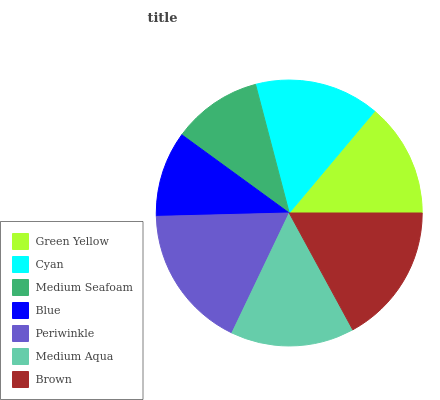Is Blue the minimum?
Answer yes or no. Yes. Is Periwinkle the maximum?
Answer yes or no. Yes. Is Cyan the minimum?
Answer yes or no. No. Is Cyan the maximum?
Answer yes or no. No. Is Cyan greater than Green Yellow?
Answer yes or no. Yes. Is Green Yellow less than Cyan?
Answer yes or no. Yes. Is Green Yellow greater than Cyan?
Answer yes or no. No. Is Cyan less than Green Yellow?
Answer yes or no. No. Is Medium Aqua the high median?
Answer yes or no. Yes. Is Medium Aqua the low median?
Answer yes or no. Yes. Is Blue the high median?
Answer yes or no. No. Is Periwinkle the low median?
Answer yes or no. No. 